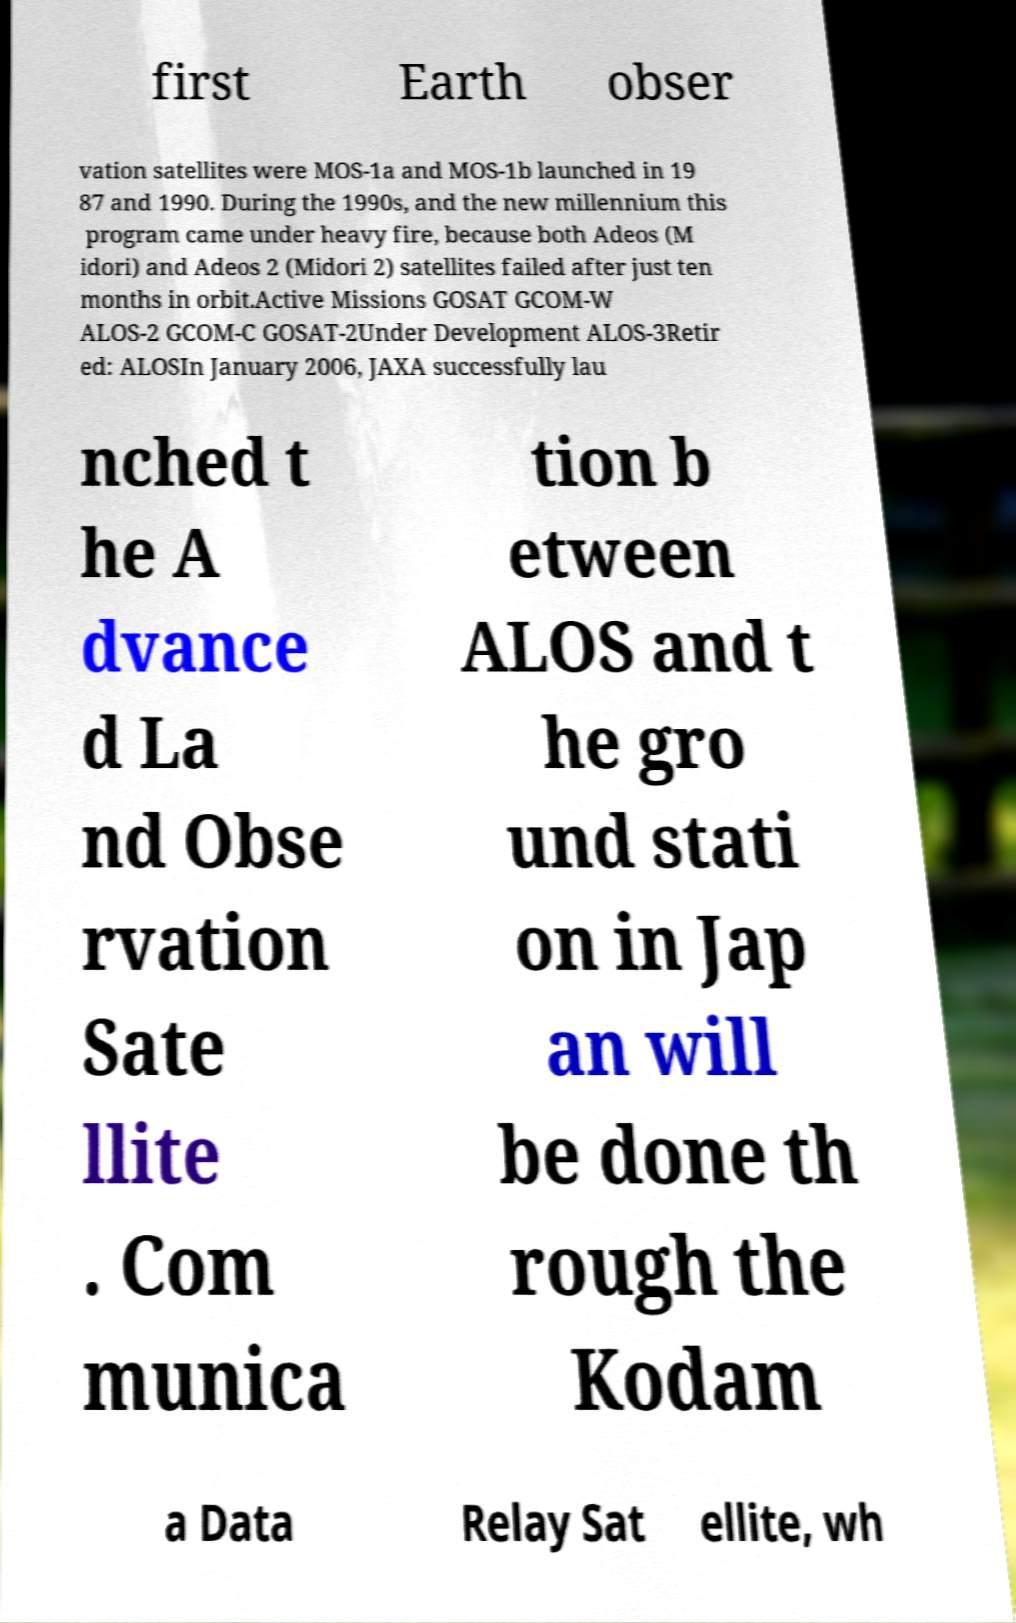Could you assist in decoding the text presented in this image and type it out clearly? first Earth obser vation satellites were MOS-1a and MOS-1b launched in 19 87 and 1990. During the 1990s, and the new millennium this program came under heavy fire, because both Adeos (M idori) and Adeos 2 (Midori 2) satellites failed after just ten months in orbit.Active Missions GOSAT GCOM-W ALOS-2 GCOM-C GOSAT-2Under Development ALOS-3Retir ed: ALOSIn January 2006, JAXA successfully lau nched t he A dvance d La nd Obse rvation Sate llite . Com munica tion b etween ALOS and t he gro und stati on in Jap an will be done th rough the Kodam a Data Relay Sat ellite, wh 